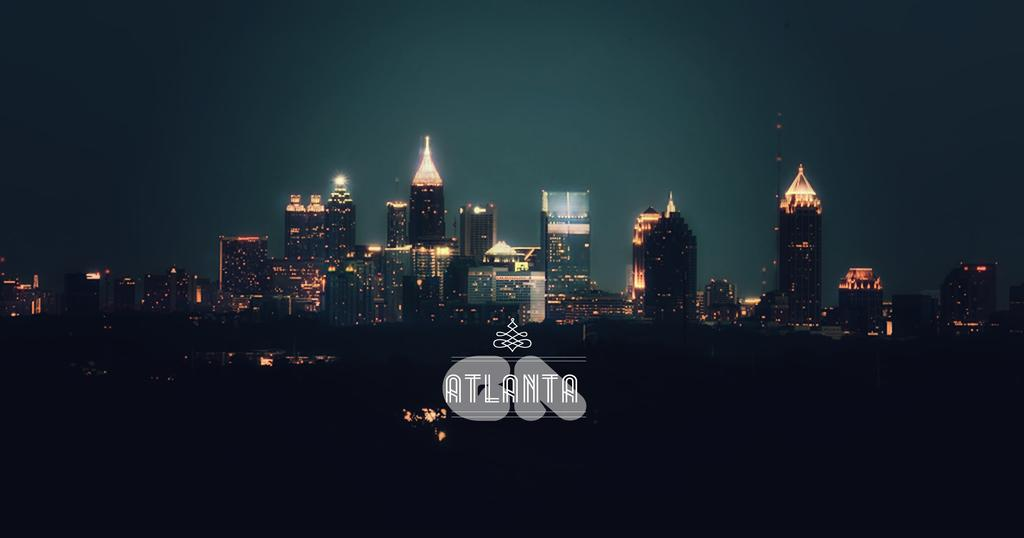<image>
Summarize the visual content of the image. An image of the Atlanta skyline at night with a group of lit up skyscrapers. 